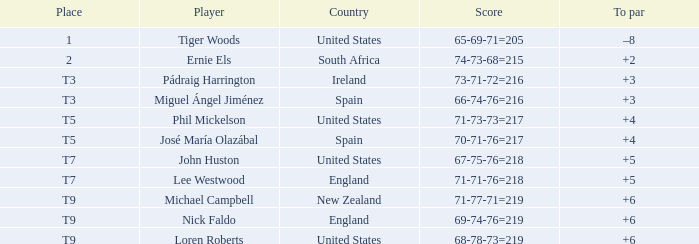What is Player, when Score is "66-74-76=216"? Miguel Ángel Jiménez. 